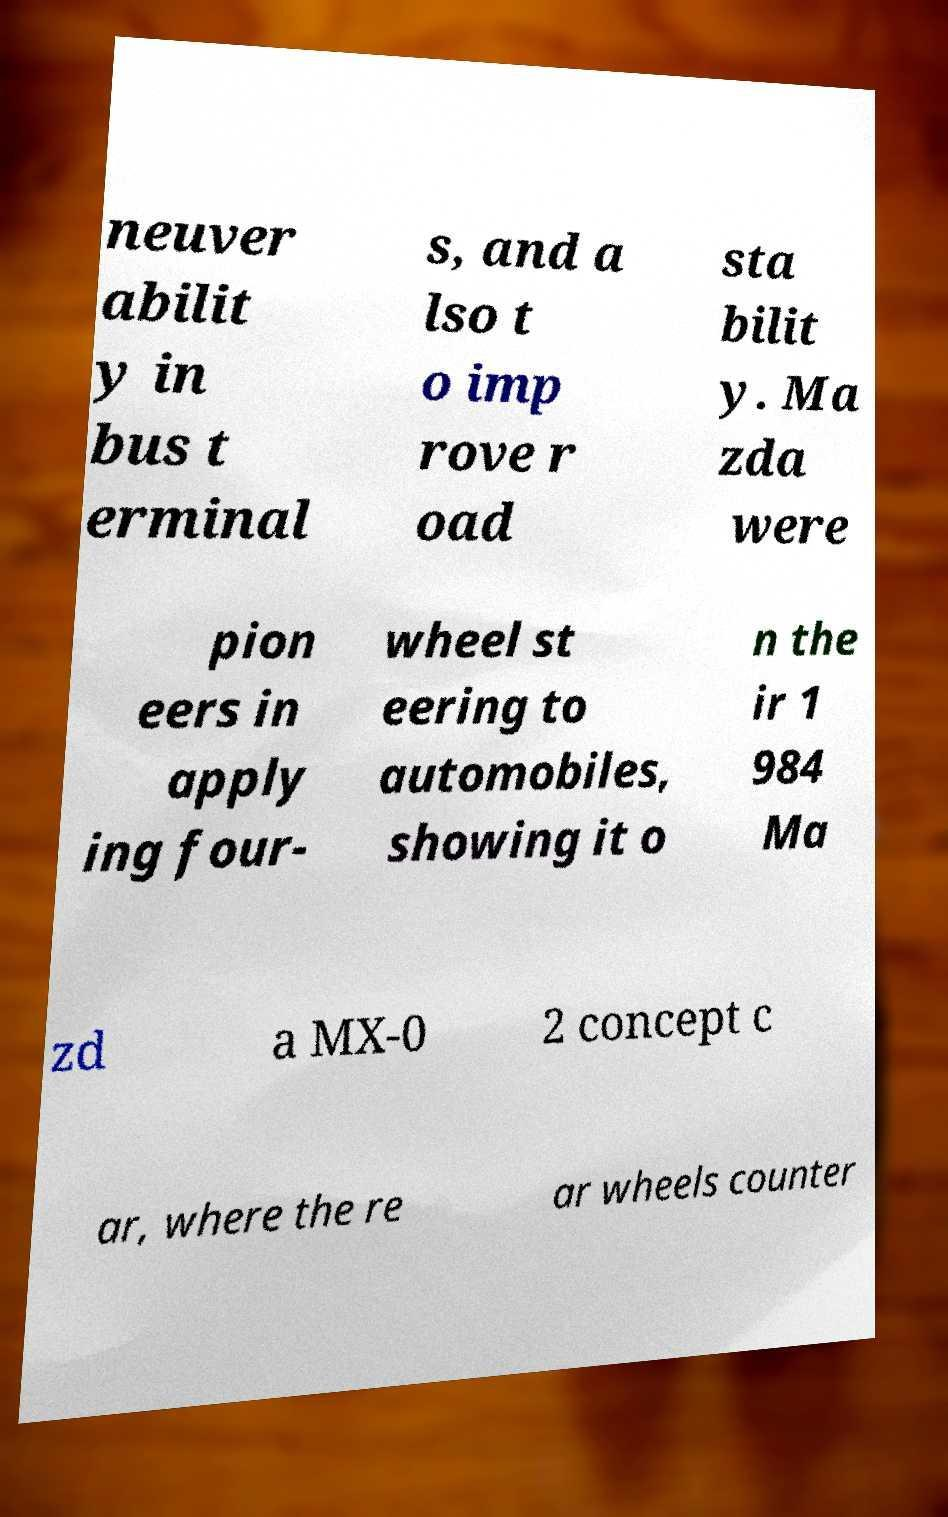There's text embedded in this image that I need extracted. Can you transcribe it verbatim? neuver abilit y in bus t erminal s, and a lso t o imp rove r oad sta bilit y. Ma zda were pion eers in apply ing four- wheel st eering to automobiles, showing it o n the ir 1 984 Ma zd a MX-0 2 concept c ar, where the re ar wheels counter 